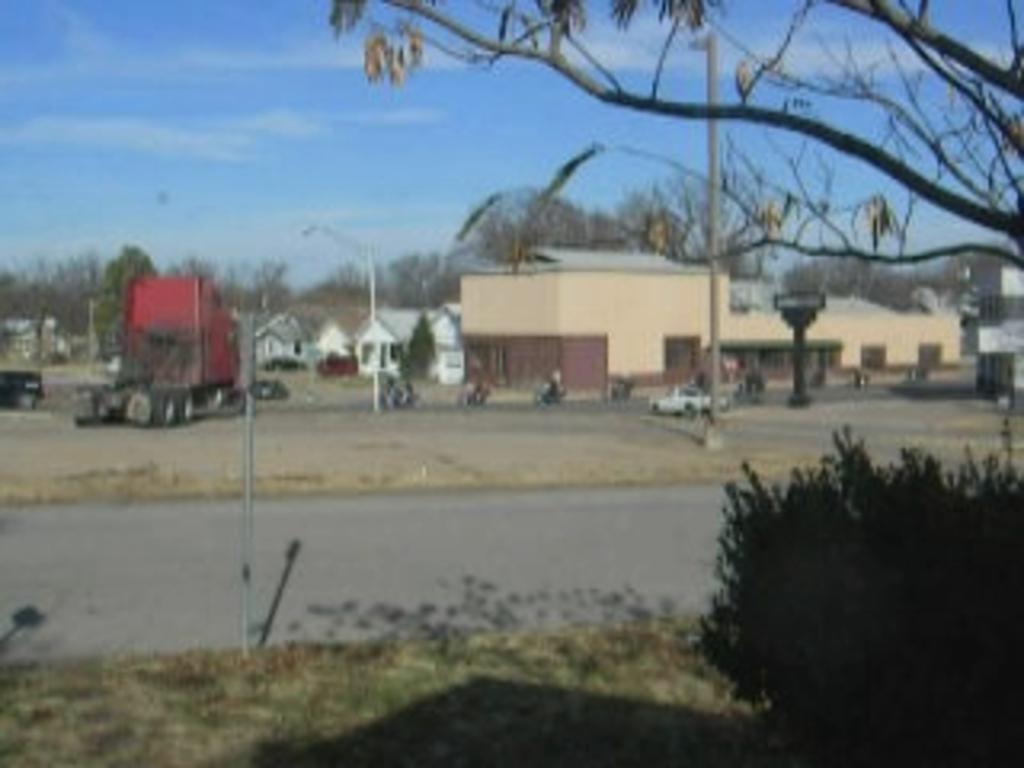Can you describe this image briefly? In this image we can see few buildings, trees, vehicles on the ground, light poles, a pole with board and the sky in the background. 